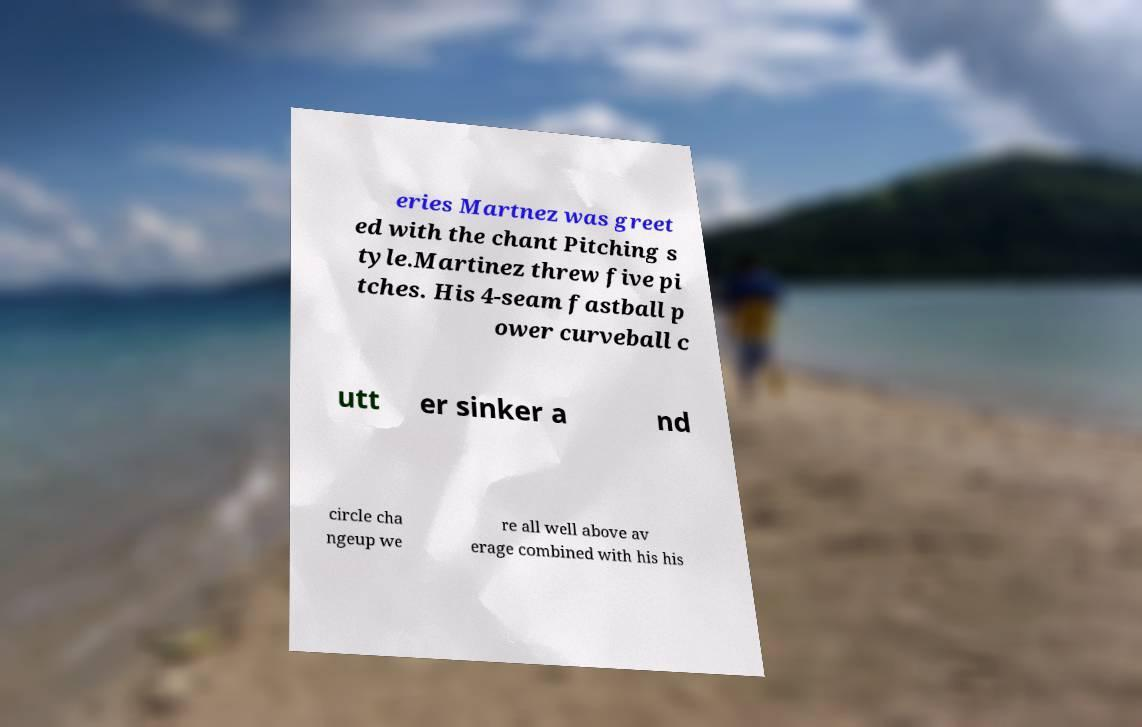Can you accurately transcribe the text from the provided image for me? eries Martnez was greet ed with the chant Pitching s tyle.Martinez threw five pi tches. His 4-seam fastball p ower curveball c utt er sinker a nd circle cha ngeup we re all well above av erage combined with his his 